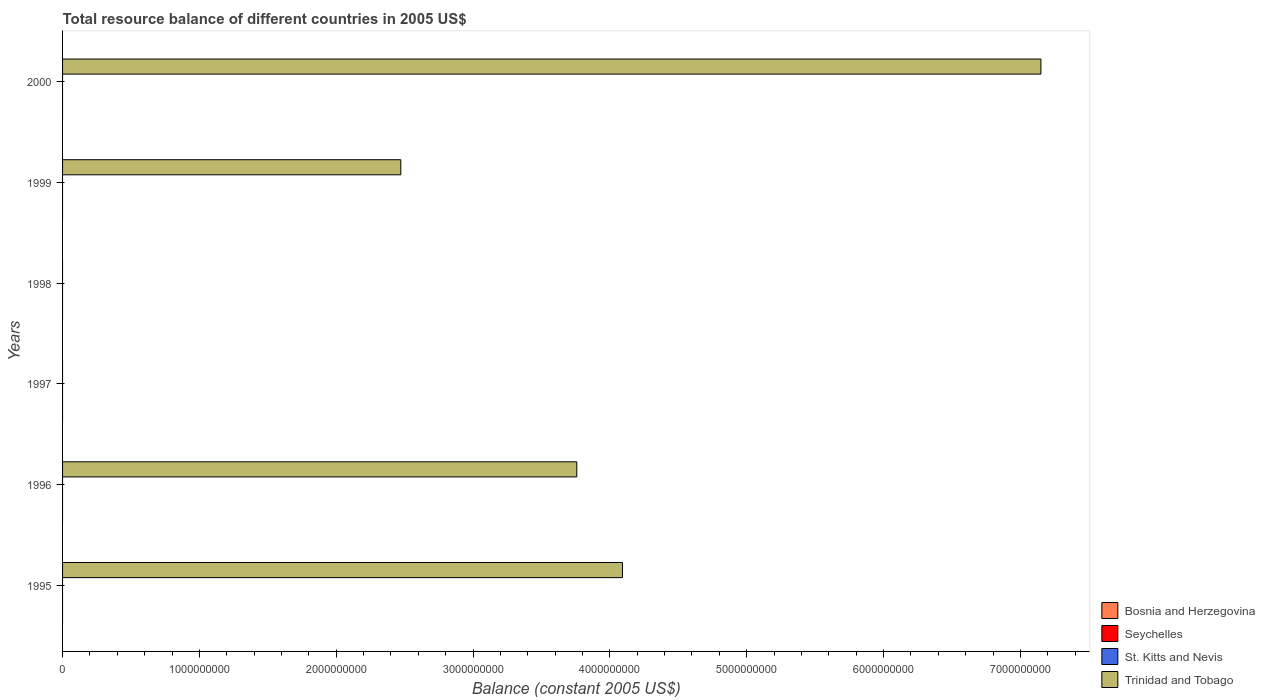Are the number of bars per tick equal to the number of legend labels?
Your answer should be compact. No. What is the label of the 2nd group of bars from the top?
Give a very brief answer. 1999. What is the total resource balance in Trinidad and Tobago in 1996?
Provide a succinct answer. 3.76e+09. Across all years, what is the maximum total resource balance in Trinidad and Tobago?
Offer a terse response. 7.15e+09. Across all years, what is the minimum total resource balance in Bosnia and Herzegovina?
Offer a very short reply. 0. What is the difference between the total resource balance in Bosnia and Herzegovina in 1998 and the total resource balance in Trinidad and Tobago in 1997?
Your response must be concise. 0. What is the average total resource balance in Seychelles per year?
Your response must be concise. 0. What is the difference between the highest and the second highest total resource balance in Trinidad and Tobago?
Provide a short and direct response. 3.06e+09. What is the difference between the highest and the lowest total resource balance in Trinidad and Tobago?
Ensure brevity in your answer.  7.15e+09. Are all the bars in the graph horizontal?
Offer a terse response. Yes. How many years are there in the graph?
Your answer should be compact. 6. What is the difference between two consecutive major ticks on the X-axis?
Give a very brief answer. 1.00e+09. Does the graph contain any zero values?
Provide a succinct answer. Yes. Where does the legend appear in the graph?
Keep it short and to the point. Bottom right. What is the title of the graph?
Your response must be concise. Total resource balance of different countries in 2005 US$. Does "Nicaragua" appear as one of the legend labels in the graph?
Provide a short and direct response. No. What is the label or title of the X-axis?
Your answer should be compact. Balance (constant 2005 US$). What is the label or title of the Y-axis?
Provide a succinct answer. Years. What is the Balance (constant 2005 US$) of Bosnia and Herzegovina in 1995?
Ensure brevity in your answer.  0. What is the Balance (constant 2005 US$) of Seychelles in 1995?
Your response must be concise. 0. What is the Balance (constant 2005 US$) in St. Kitts and Nevis in 1995?
Your answer should be compact. 0. What is the Balance (constant 2005 US$) in Trinidad and Tobago in 1995?
Your response must be concise. 4.09e+09. What is the Balance (constant 2005 US$) in Seychelles in 1996?
Your response must be concise. 0. What is the Balance (constant 2005 US$) of Trinidad and Tobago in 1996?
Give a very brief answer. 3.76e+09. What is the Balance (constant 2005 US$) in Bosnia and Herzegovina in 1997?
Provide a succinct answer. 0. What is the Balance (constant 2005 US$) in Bosnia and Herzegovina in 1998?
Your answer should be compact. 0. What is the Balance (constant 2005 US$) of Seychelles in 1998?
Offer a very short reply. 0. What is the Balance (constant 2005 US$) in Trinidad and Tobago in 1998?
Ensure brevity in your answer.  0. What is the Balance (constant 2005 US$) in Bosnia and Herzegovina in 1999?
Provide a short and direct response. 0. What is the Balance (constant 2005 US$) of St. Kitts and Nevis in 1999?
Ensure brevity in your answer.  0. What is the Balance (constant 2005 US$) in Trinidad and Tobago in 1999?
Offer a very short reply. 2.47e+09. What is the Balance (constant 2005 US$) of Bosnia and Herzegovina in 2000?
Your answer should be very brief. 0. What is the Balance (constant 2005 US$) in Trinidad and Tobago in 2000?
Offer a very short reply. 7.15e+09. Across all years, what is the maximum Balance (constant 2005 US$) in Trinidad and Tobago?
Provide a short and direct response. 7.15e+09. Across all years, what is the minimum Balance (constant 2005 US$) of Trinidad and Tobago?
Your response must be concise. 0. What is the total Balance (constant 2005 US$) in St. Kitts and Nevis in the graph?
Ensure brevity in your answer.  0. What is the total Balance (constant 2005 US$) of Trinidad and Tobago in the graph?
Your answer should be compact. 1.75e+1. What is the difference between the Balance (constant 2005 US$) of Trinidad and Tobago in 1995 and that in 1996?
Your answer should be very brief. 3.34e+08. What is the difference between the Balance (constant 2005 US$) of Trinidad and Tobago in 1995 and that in 1999?
Your response must be concise. 1.62e+09. What is the difference between the Balance (constant 2005 US$) in Trinidad and Tobago in 1995 and that in 2000?
Ensure brevity in your answer.  -3.06e+09. What is the difference between the Balance (constant 2005 US$) in Trinidad and Tobago in 1996 and that in 1999?
Offer a very short reply. 1.29e+09. What is the difference between the Balance (constant 2005 US$) of Trinidad and Tobago in 1996 and that in 2000?
Offer a terse response. -3.39e+09. What is the difference between the Balance (constant 2005 US$) of Trinidad and Tobago in 1999 and that in 2000?
Provide a short and direct response. -4.68e+09. What is the average Balance (constant 2005 US$) of Bosnia and Herzegovina per year?
Offer a very short reply. 0. What is the average Balance (constant 2005 US$) of Trinidad and Tobago per year?
Provide a short and direct response. 2.91e+09. What is the ratio of the Balance (constant 2005 US$) of Trinidad and Tobago in 1995 to that in 1996?
Keep it short and to the point. 1.09. What is the ratio of the Balance (constant 2005 US$) of Trinidad and Tobago in 1995 to that in 1999?
Ensure brevity in your answer.  1.66. What is the ratio of the Balance (constant 2005 US$) of Trinidad and Tobago in 1995 to that in 2000?
Give a very brief answer. 0.57. What is the ratio of the Balance (constant 2005 US$) of Trinidad and Tobago in 1996 to that in 1999?
Provide a short and direct response. 1.52. What is the ratio of the Balance (constant 2005 US$) in Trinidad and Tobago in 1996 to that in 2000?
Offer a very short reply. 0.53. What is the ratio of the Balance (constant 2005 US$) in Trinidad and Tobago in 1999 to that in 2000?
Give a very brief answer. 0.35. What is the difference between the highest and the second highest Balance (constant 2005 US$) in Trinidad and Tobago?
Your answer should be compact. 3.06e+09. What is the difference between the highest and the lowest Balance (constant 2005 US$) of Trinidad and Tobago?
Ensure brevity in your answer.  7.15e+09. 